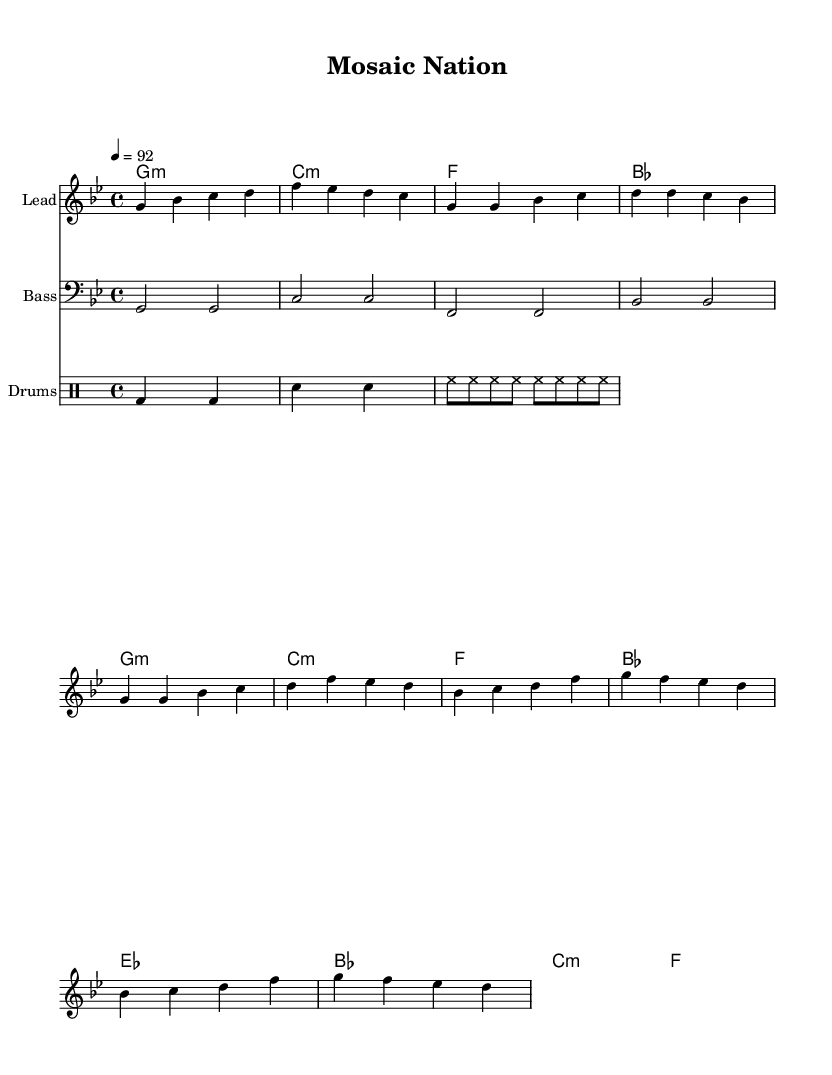What is the key signature of this music? The key signature is G minor, which has two flats (B flat and E flat). This can be observed in the beginning of the sheet music where the flats are indicated.
Answer: G minor What is the time signature of this composition? The time signature shown in the sheet music is 4/4, which means there are four beats per measure and the quarter note gets one beat. This is visible at the beginning of the score.
Answer: 4/4 What is the tempo marking for this piece? The tempo marking indicates that the piece should be played at a speed of 92 beats per minute. This is denoted by "4 = 92" at the start of the score.
Answer: 92 How many measures are in the chorus section? The chorus section consists of 4 measures, which can be counted by looking at the lines that specifically represent the chorus melody and harmonies.
Answer: 4 What musical styles are represented in this sheet music? The sheet music represents hip hop as a genre, indicated by the rhythmic patterns and instrumentation typical of hip hop music, such as the emphasis on beats and basslines, which can be deduced from the overall structure and instrumentation used.
Answer: Hip Hop What instrument is the melody played on? The melody is played on the Lead instrument, which is explicitly indicated in the staff label. This identifies the part that performs the main melodic line of the piece.
Answer: Lead What is the chord used in the introduction? The chord used for the introduction is G minor, as specified in the harmonies section at the beginning of the piece, which sets the harmonic foundation for the music.
Answer: G minor 